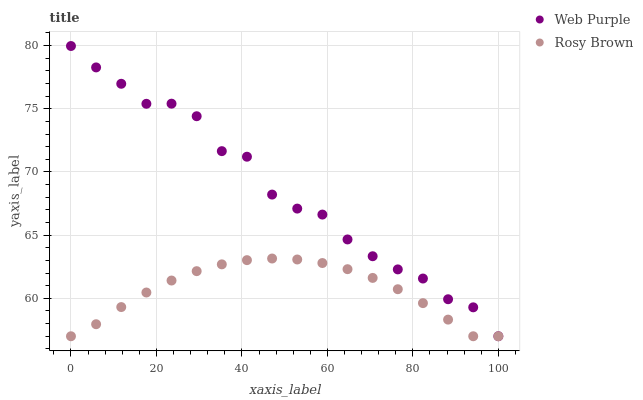Does Rosy Brown have the minimum area under the curve?
Answer yes or no. Yes. Does Web Purple have the maximum area under the curve?
Answer yes or no. Yes. Does Rosy Brown have the maximum area under the curve?
Answer yes or no. No. Is Rosy Brown the smoothest?
Answer yes or no. Yes. Is Web Purple the roughest?
Answer yes or no. Yes. Is Rosy Brown the roughest?
Answer yes or no. No. Does Web Purple have the lowest value?
Answer yes or no. Yes. Does Web Purple have the highest value?
Answer yes or no. Yes. Does Rosy Brown have the highest value?
Answer yes or no. No. Does Web Purple intersect Rosy Brown?
Answer yes or no. Yes. Is Web Purple less than Rosy Brown?
Answer yes or no. No. Is Web Purple greater than Rosy Brown?
Answer yes or no. No. 